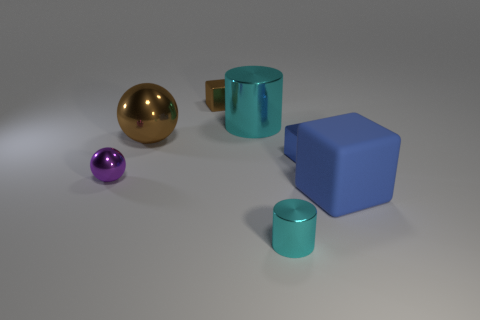There is a shiny thing that is the same color as the large metallic ball; what size is it?
Your answer should be very brief. Small. The tiny purple metal object is what shape?
Make the answer very short. Sphere. What is the shape of the large object right of the small shiny cube that is on the right side of the brown metal cube?
Your answer should be very brief. Cube. Is the material of the cube behind the big brown thing the same as the tiny ball?
Your answer should be compact. Yes. How many yellow things are large rubber cubes or cylinders?
Make the answer very short. 0. Are there any metallic cubes that have the same color as the big ball?
Provide a short and direct response. Yes. Is there a big cyan thing made of the same material as the large blue cube?
Keep it short and to the point. No. The object that is behind the large blue cube and on the right side of the tiny cyan shiny cylinder has what shape?
Make the answer very short. Cube. What number of small objects are either brown matte spheres or blue cubes?
Give a very brief answer. 1. What is the tiny purple ball made of?
Your answer should be compact. Metal. 